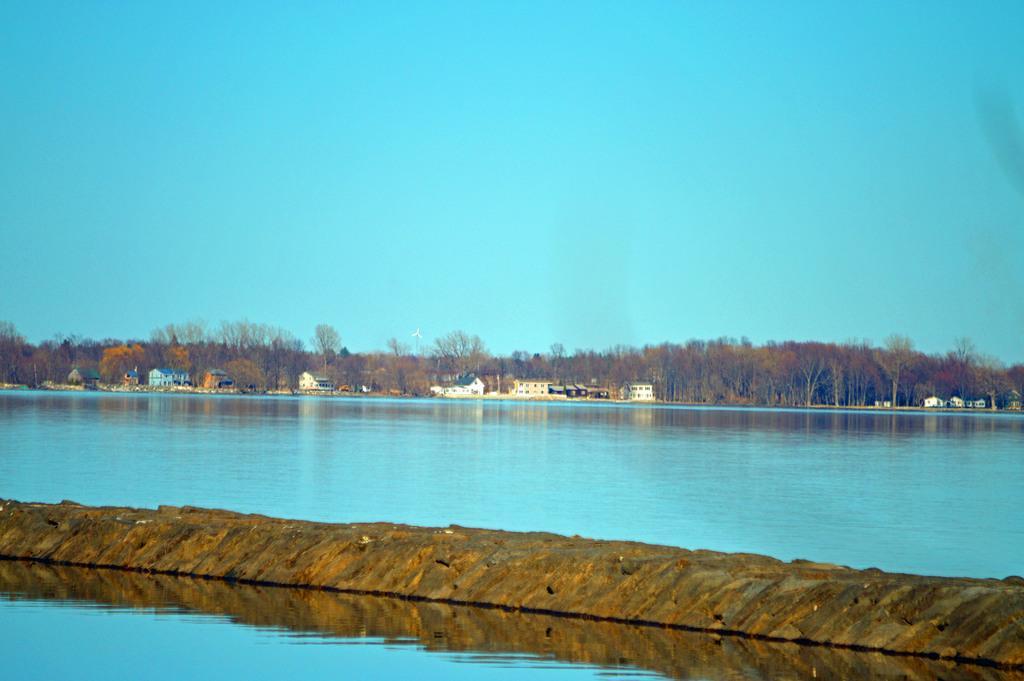Could you give a brief overview of what you see in this image? In this image at the bottom we can see water and platform. In the background we can see water, trees, houses and sky. 